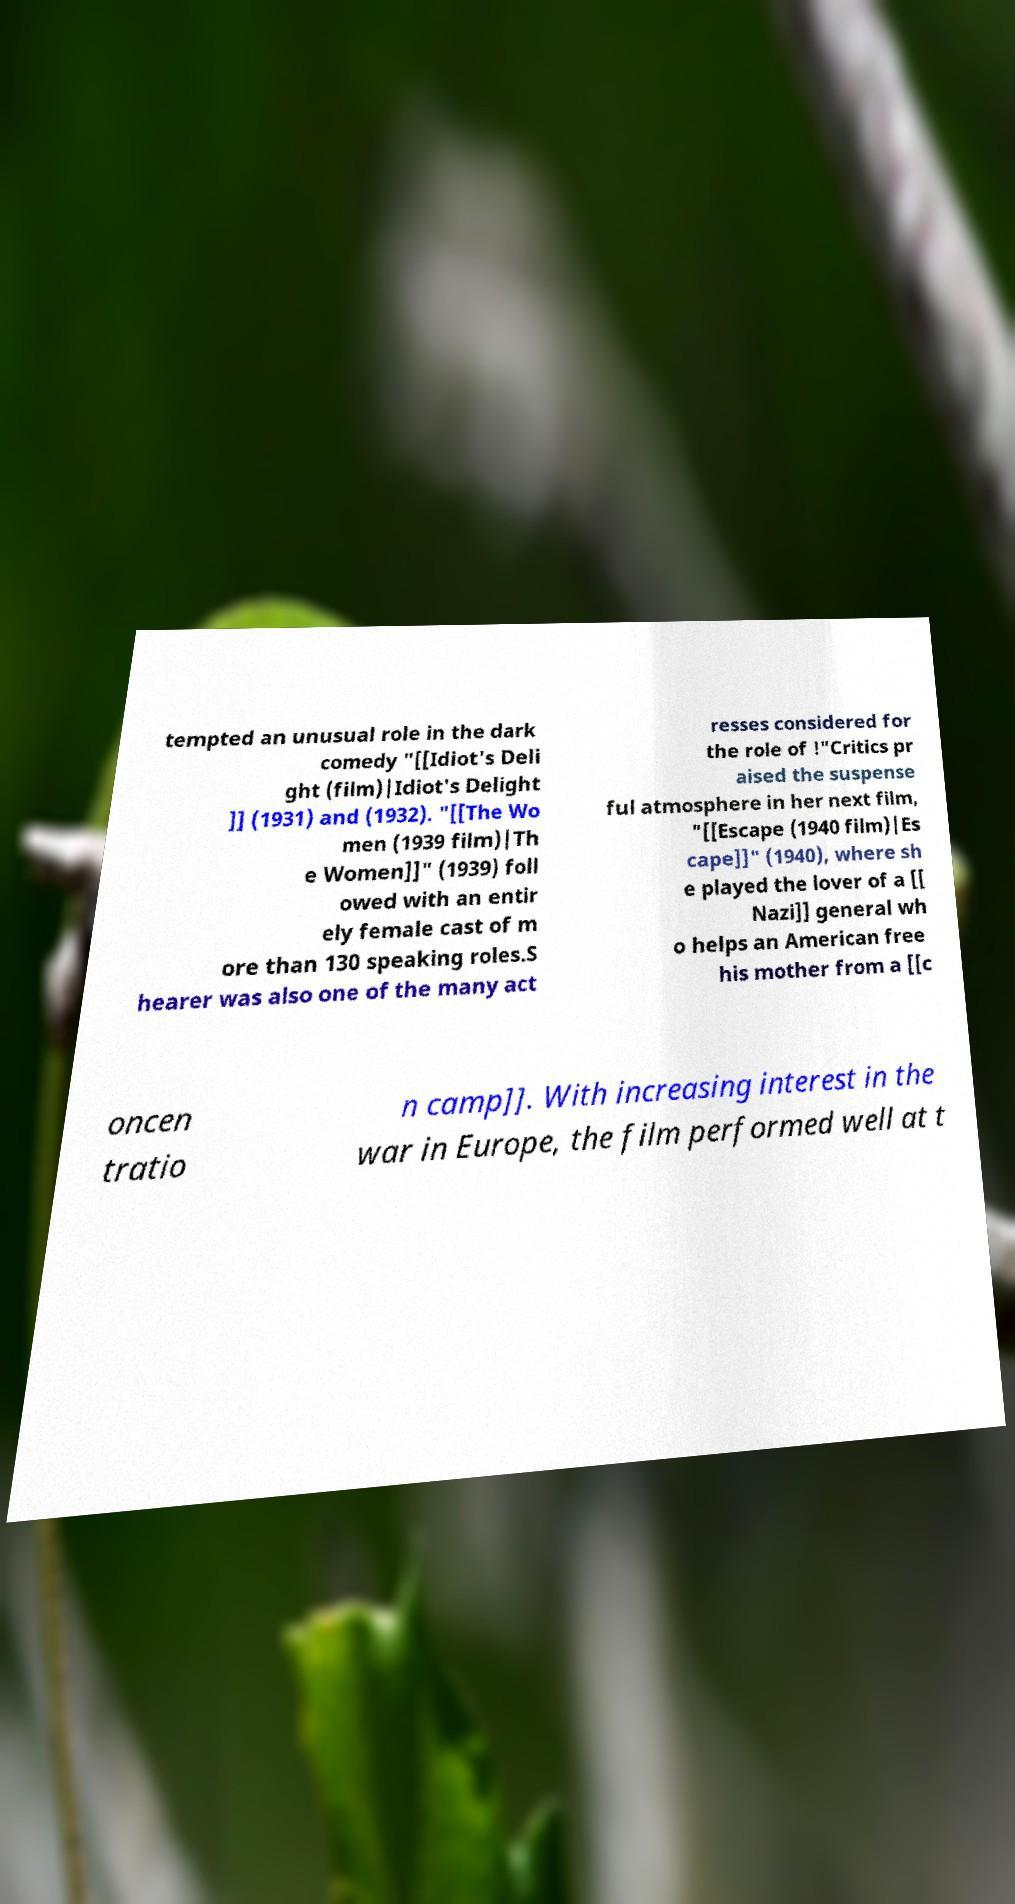Please identify and transcribe the text found in this image. tempted an unusual role in the dark comedy "[[Idiot's Deli ght (film)|Idiot's Delight ]] (1931) and (1932). "[[The Wo men (1939 film)|Th e Women]]" (1939) foll owed with an entir ely female cast of m ore than 130 speaking roles.S hearer was also one of the many act resses considered for the role of !"Critics pr aised the suspense ful atmosphere in her next film, "[[Escape (1940 film)|Es cape]]" (1940), where sh e played the lover of a [[ Nazi]] general wh o helps an American free his mother from a [[c oncen tratio n camp]]. With increasing interest in the war in Europe, the film performed well at t 